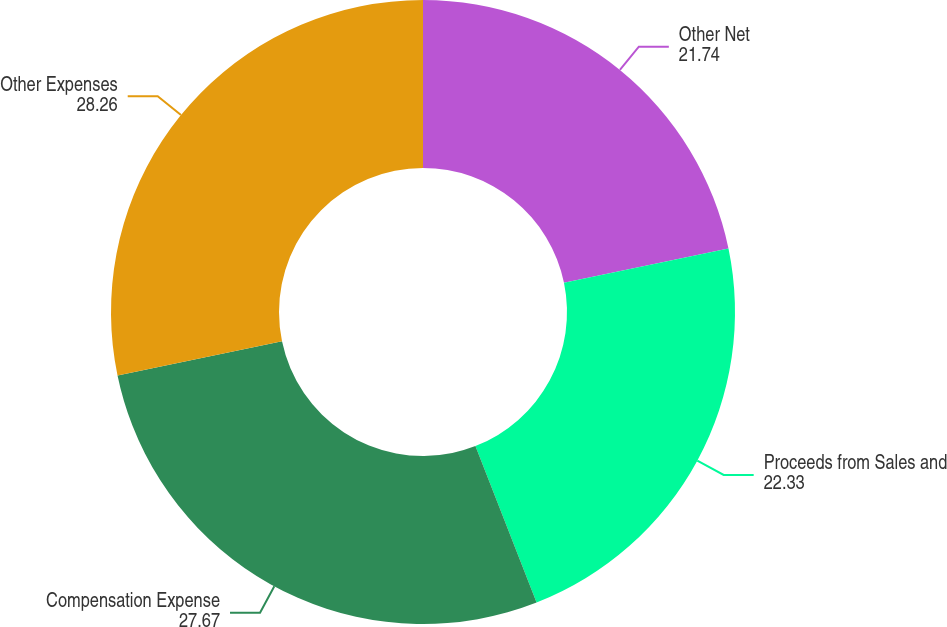<chart> <loc_0><loc_0><loc_500><loc_500><pie_chart><fcel>Other Net<fcel>Proceeds from Sales and<fcel>Compensation Expense<fcel>Other Expenses<nl><fcel>21.74%<fcel>22.33%<fcel>27.67%<fcel>28.26%<nl></chart> 